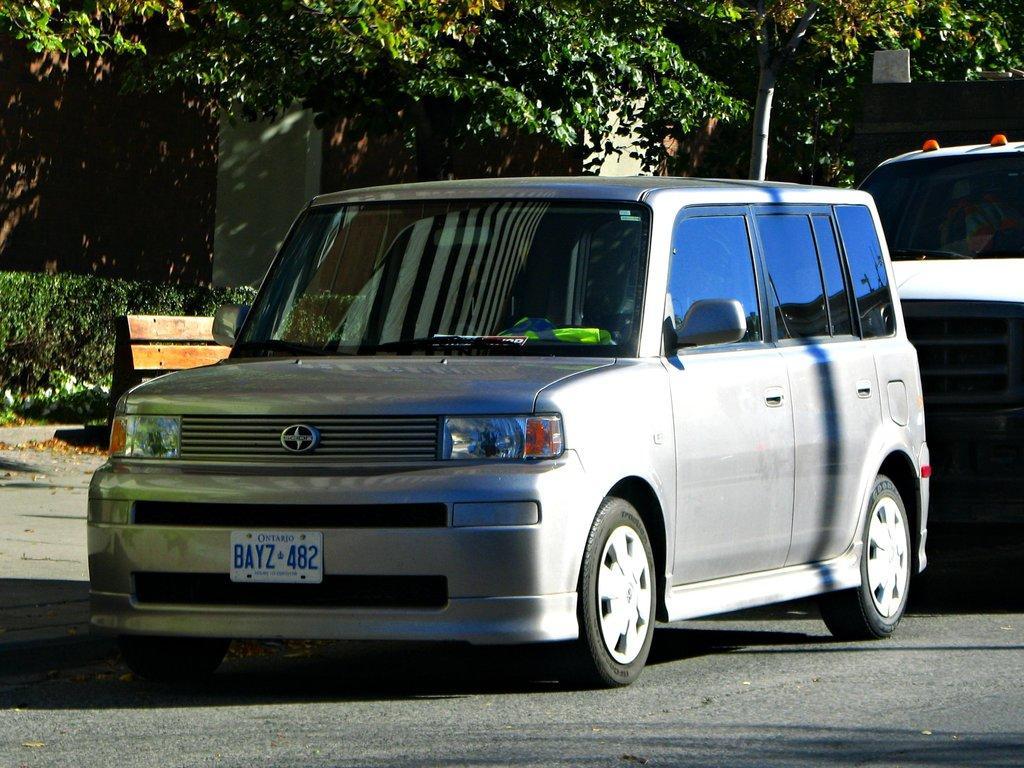How would you summarize this image in a sentence or two? In this picture we can see two cars, in the background there are trees and a house, on the left side we can see a bench and shrubs. 